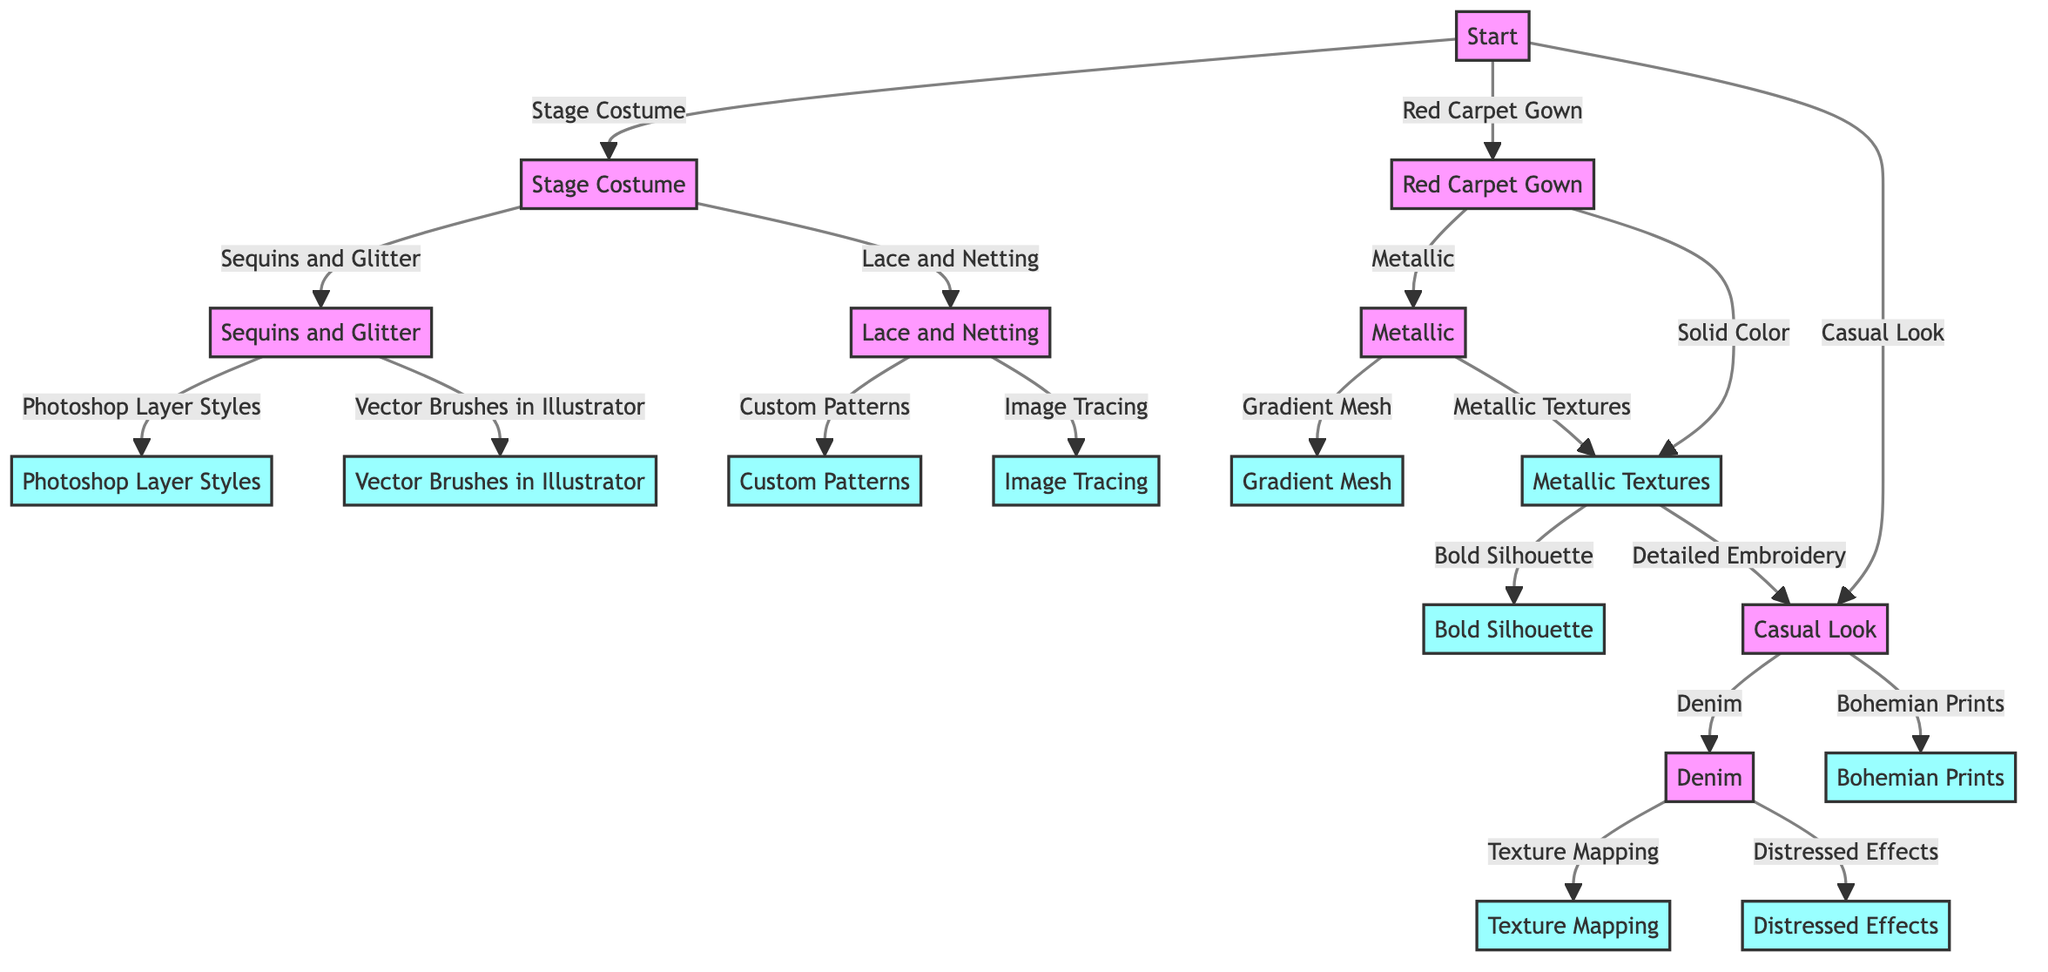What type of outfits can be replicated according to the decision tree? The decision tree outlines three types of outfits that can be replicated: Stage Costume, Red Carpet Gown, and Casual Look.
Answer: Stage Costume, Red Carpet Gown, Casual Look How many nodes are in the decision tree? The decision tree consists of a total of 18 nodes, including the start node and terminal result nodes.
Answer: 18 Which digital technique is suggested for Sequins and Glitter? The node connected to Sequins and Glitter offers two options: Photoshop Layer Styles and Vector Brushes in Illustrator. The first option leads to the results node stating to apply blending options for a realistic sequin effect.
Answer: Photoshop Layer Styles What question is asked for Red Carpet Gown in the decision tree? The decision tree asks for the dominant color of the gown when the user selects Red Carpet Gown, indicating it guides to distinguish between different approaches.
Answer: What is the dominant color of the gown? What is the result for the Digital Art Technique chosen for Detailed Embroidery? The decision tree leads to a result that suggests using custom brushes and intricate vector designs to replicate the detailed embroidery patterns.
Answer: Use custom brushes and intricate vector designs If you select Lace and Netting as the dominant material, which two techniques are available? The node for Lace and Netting presents two options: Custom Patterns and Image Tracing as the potential techniques to implement for digital artwork.
Answer: Custom Patterns, Image Tracing What happens if the primary element of the Casual Look is Bohemian Prints? Selecting Bohemian Prints leads to a result that indicates designing custom bohemian patterns and using color swatches to reflect the style, emphasizing the unique artistic representation of Cher's casual looks.
Answer: Design custom bohemian patterns Which technique is indicated for creating a shiny, gradient effect that simulates metallic fabric? The node connected to Gradient Mesh specifically states to use Adobe Illustrator's Gradient Mesh tool to create a shiny gradient effect for metallic fabrics.
Answer: Gradient Mesh 